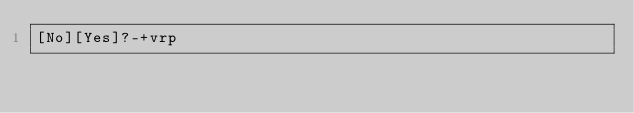<code> <loc_0><loc_0><loc_500><loc_500><_dc_>[No][Yes]?-+vrp</code> 